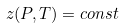Convert formula to latex. <formula><loc_0><loc_0><loc_500><loc_500>z ( P , T ) = c o n s t</formula> 